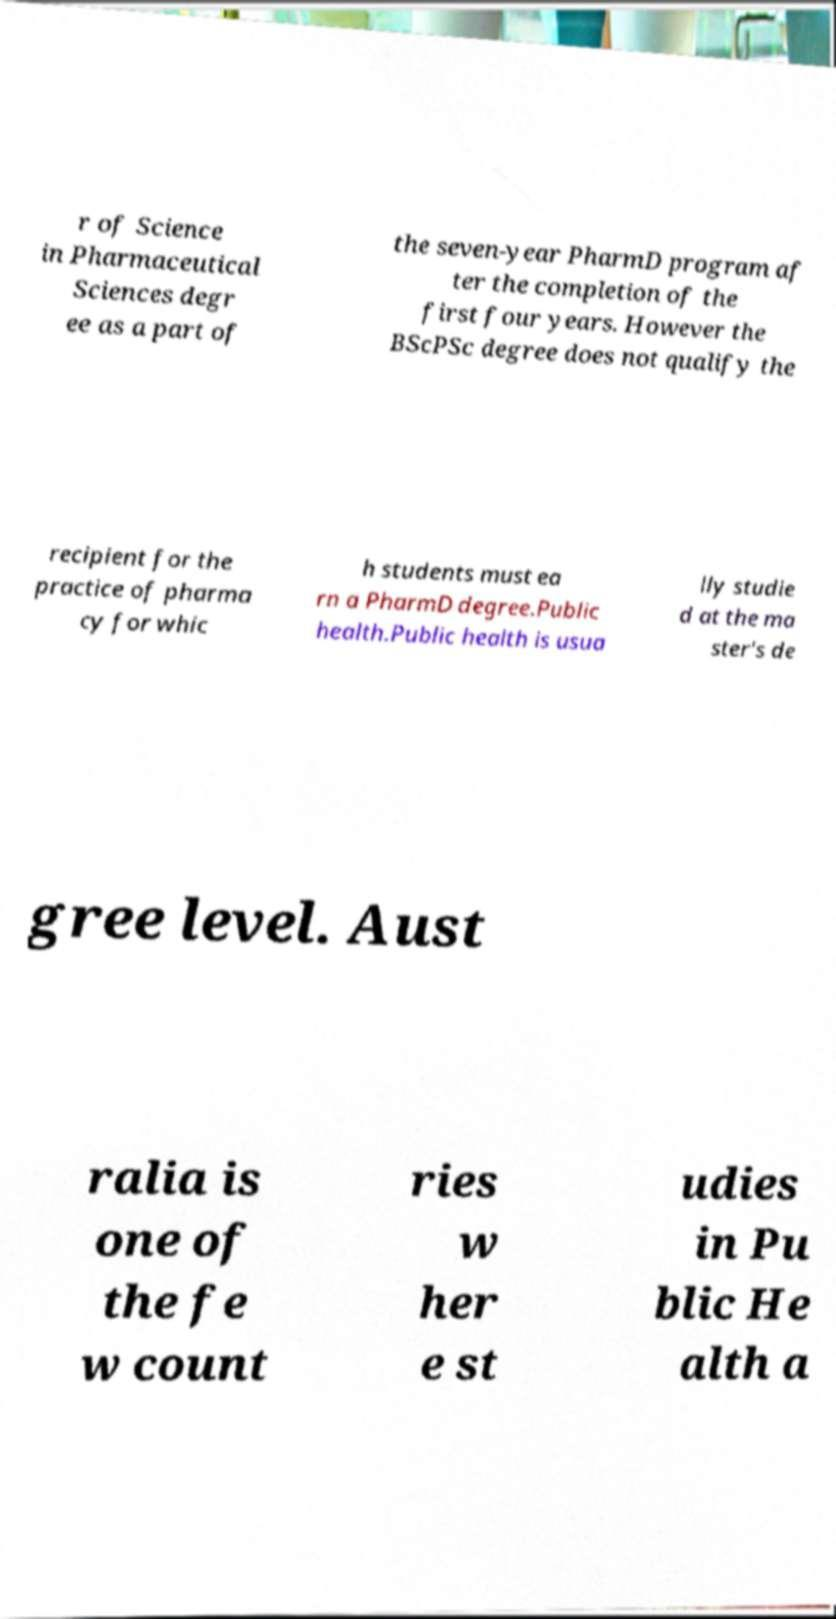Please read and relay the text visible in this image. What does it say? r of Science in Pharmaceutical Sciences degr ee as a part of the seven-year PharmD program af ter the completion of the first four years. However the BScPSc degree does not qualify the recipient for the practice of pharma cy for whic h students must ea rn a PharmD degree.Public health.Public health is usua lly studie d at the ma ster's de gree level. Aust ralia is one of the fe w count ries w her e st udies in Pu blic He alth a 